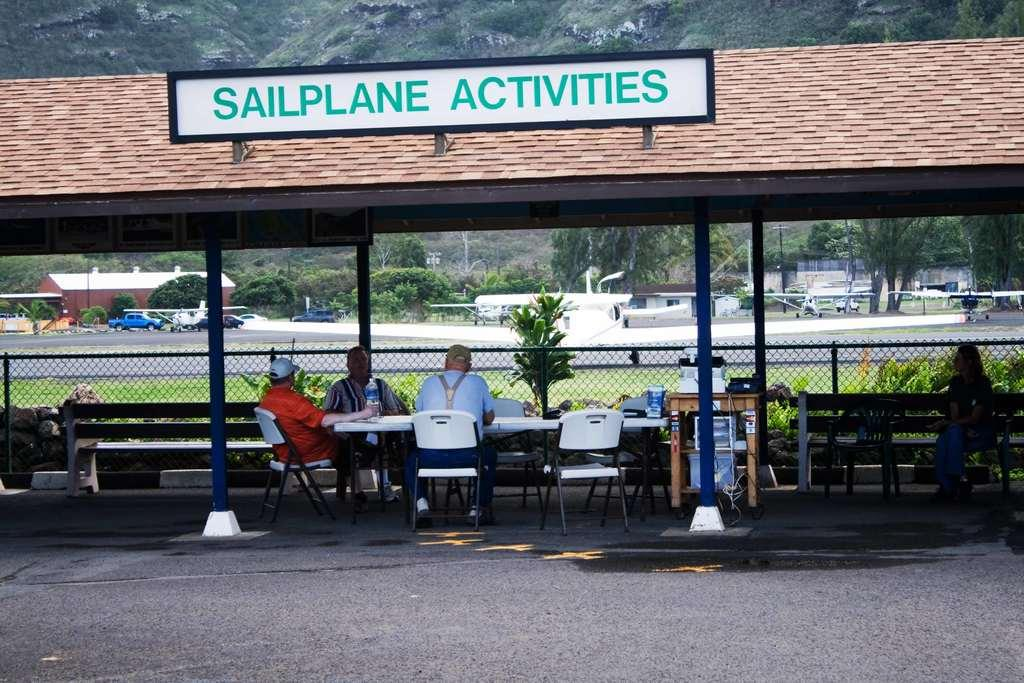How many men are in the image? There are three men in the image. What are the men doing in the image? The men are sitting on chairs. Where are the chairs located in relation to the table? The chairs are around a table. What is the location of the table in the image? The table is under a shed. What can be seen in the background of the image? There are planes, cars, and trees in the background of the image. What type of pigs can be seen running around the shed in the image? There are no pigs present in the image; it features three men sitting around a table under a shed, with planes, cars, and trees visible in the background. 